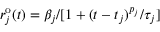Convert formula to latex. <formula><loc_0><loc_0><loc_500><loc_500>r _ { j } ^ { o } ( t ) = \beta _ { j } / [ 1 + ( t - t _ { j } ) ^ { p _ { j } } / \tau _ { j } ]</formula> 